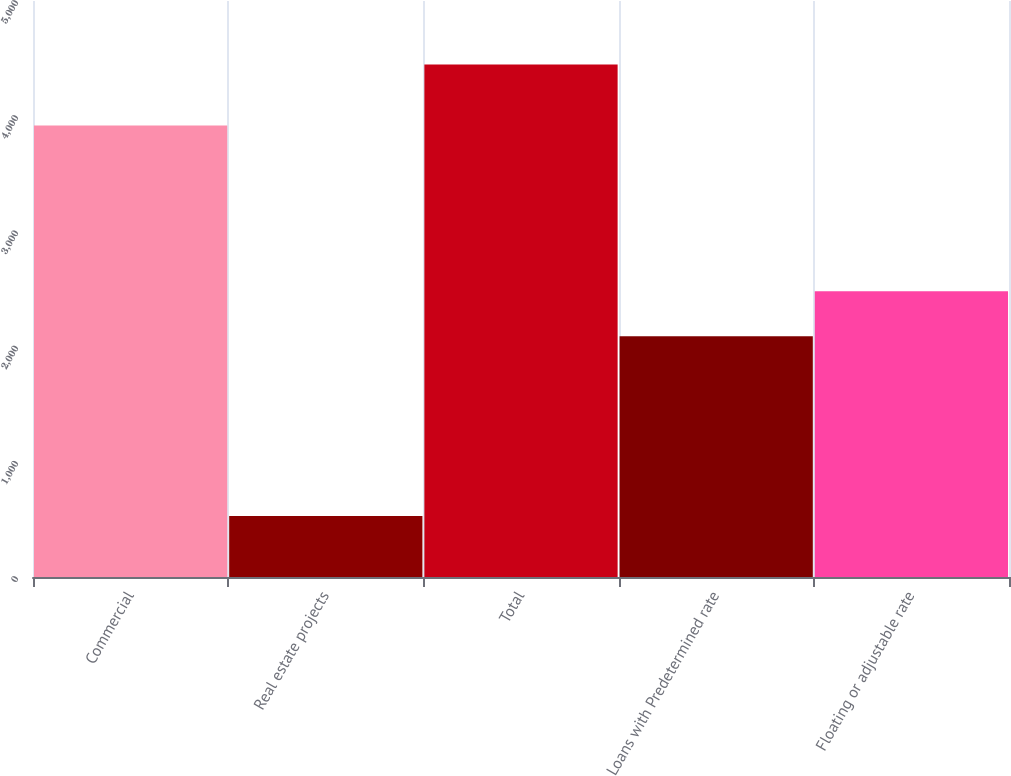Convert chart to OTSL. <chart><loc_0><loc_0><loc_500><loc_500><bar_chart><fcel>Commercial<fcel>Real estate projects<fcel>Total<fcel>Loans with Predetermined rate<fcel>Floating or adjustable rate<nl><fcel>3920<fcel>529<fcel>4449<fcel>2089<fcel>2481<nl></chart> 